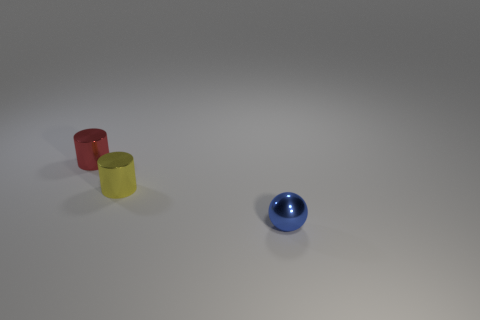There is a cylinder that is in front of the shiny cylinder on the left side of the cylinder that is in front of the tiny red metallic thing; what is its size?
Offer a very short reply. Small. Are any tiny red things visible?
Your answer should be very brief. Yes. What number of tiny shiny things have the same color as the tiny ball?
Give a very brief answer. 0. How many objects are either objects that are on the left side of the small blue metallic ball or things left of the metallic sphere?
Your response must be concise. 2. There is a cylinder to the right of the small red metal cylinder; how many tiny yellow things are left of it?
Make the answer very short. 0. There is a small cylinder that is made of the same material as the small yellow thing; what color is it?
Offer a very short reply. Red. Are there any yellow metal cylinders of the same size as the red shiny object?
Offer a terse response. Yes. There is a blue metallic object that is the same size as the red metallic cylinder; what is its shape?
Your answer should be compact. Sphere. Are there any small red objects of the same shape as the yellow object?
Make the answer very short. Yes. Do the yellow thing and the tiny cylinder behind the yellow metallic thing have the same material?
Offer a very short reply. Yes. 